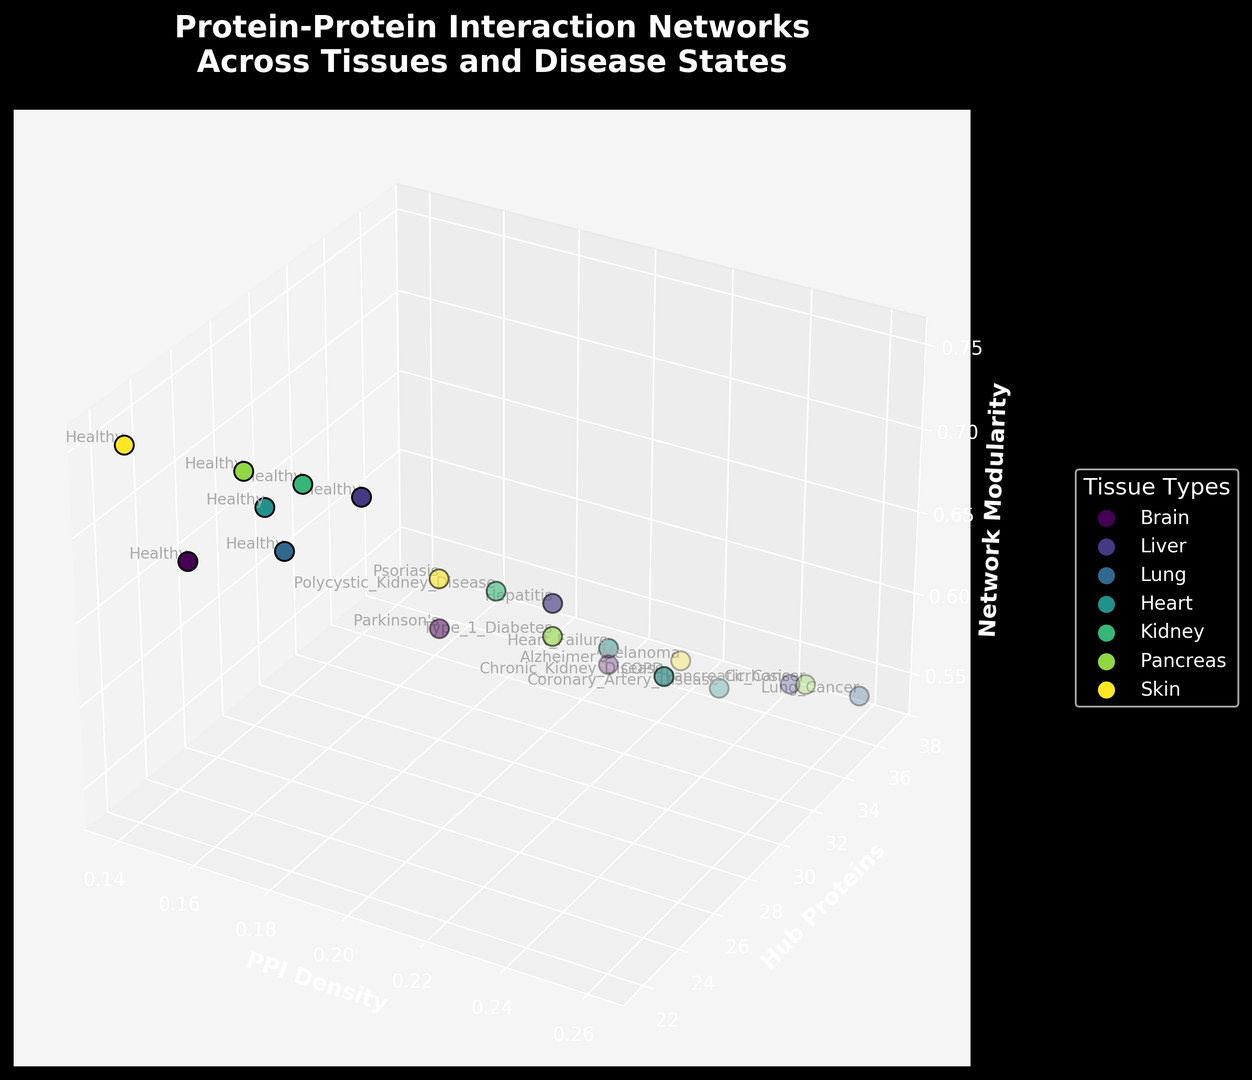What color represents the Brain tissue in the plot? The figure uses different colors to represent each tissue type. Identify the color associated with the Brain tissue from the legend.
Answer: Varies depending on rendering but can be identified in the legend Which disease state in the liver has the highest network modularity? Look at the y-axis (Network Modularity) values for all liver disease states and find the highest value. The highest value corresponds to the "Healthy" state.
Answer: Healthy Compare the PPI Density between Parkinson's and Alzheimer's in the brain. Which one is higher? Locate the Brain tissue points and compare the PPI Density on the x-axis for Alzheimer's and Parkinson's. The point for Alzheimer's shows a higher PPI Density (0.22) compared to Parkinson's (0.19).
Answer: Alzheimer's What is the average number of Hub Proteins for healthy states across all tissues? Find all points labeled as "Healthy" and note the Hub Proteins values. Calculate the average: (23+26+24+25+25+24+22)/7 = 24.14
Answer: 24.14 Which tissue type has the lowest PPI Density in any disease state? Examine the PPI Density values along the x-axis for each tissue type and identify the lowest value. The Skin tissue in a Healthy state has the lowest PPI Density (0.14).
Answer: Skin Does the Network Modularity generally increase or decrease with disease states in the heart? Observe the trend of Network Modularity on the z-axis for Heart tissue across different disease states (Healthy, Coronary Artery Disease, Heart Failure) and note the pattern. It generally decreases (from 0.70 to 0.60).
Answer: Decrease Which disease state in the lung has the highest number of Hub Proteins? Compare the number of Hub Proteins (y-axis) for all lung disease states; Lung Cancer has the highest number (37).
Answer: Lung Cancer For Type 1 Diabetes in the pancreas, how does the PPI Density compare to the healthy state in the same tissue? Compare the PPI Density (x-axis) for Healthy and Type 1 Diabetes states in the Pancreas tissue. Type 1 Diabetes (0.21) has a higher PPI Density than Healthy (0.16).
Answer: Type 1 Diabetes What is the difference in Network Modularity between Healthy and Melanoma states in the skin? Note the Network Modularity (z-axis) for Healthy (0.75) and Melanoma (0.58) states in the Skin tissue and calculate the difference. The difference is 0.75 - 0.58 = 0.17.
Answer: 0.17 